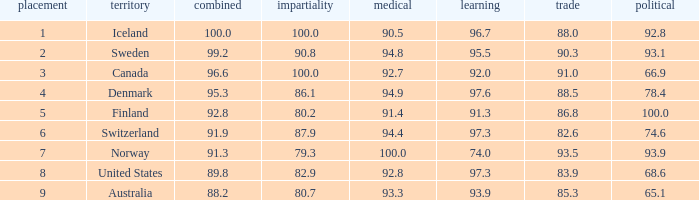What's the rank for iceland 1.0. 